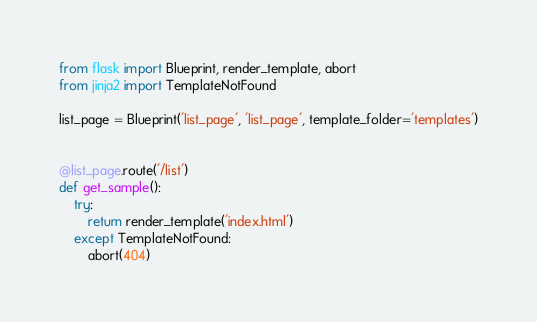Convert code to text. <code><loc_0><loc_0><loc_500><loc_500><_Python_>from flask import Blueprint, render_template, abort
from jinja2 import TemplateNotFound

list_page = Blueprint('list_page', 'list_page', template_folder='templates')


@list_page.route('/list')
def get_sample():
    try:
        return render_template('index.html')
    except TemplateNotFound:
        abort(404)
</code> 